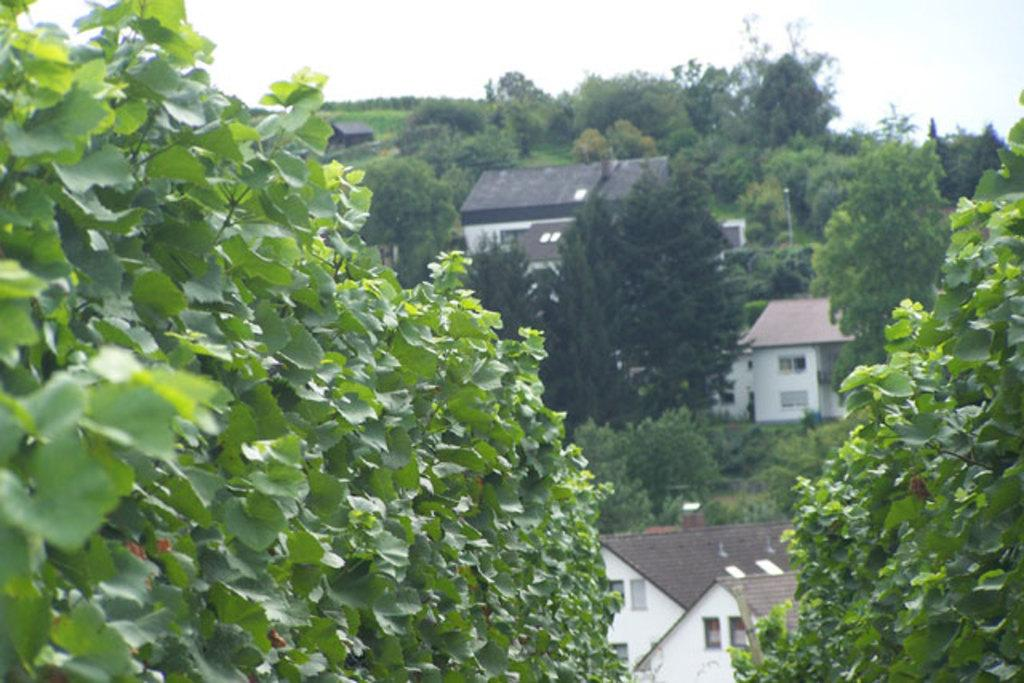What type of structures can be seen in the image? There are buildings in the image. What natural elements are present in the image? There are many trees and plants in the image. What part of the natural environment is visible in the image? The sky is visible in the image. What type of coal is being used to power the buildings in the image? There is no mention of coal or any power source in the image; it simply shows buildings, trees, plants, and the sky. 